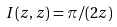<formula> <loc_0><loc_0><loc_500><loc_500>I ( z , z ) = \pi / ( 2 z )</formula> 